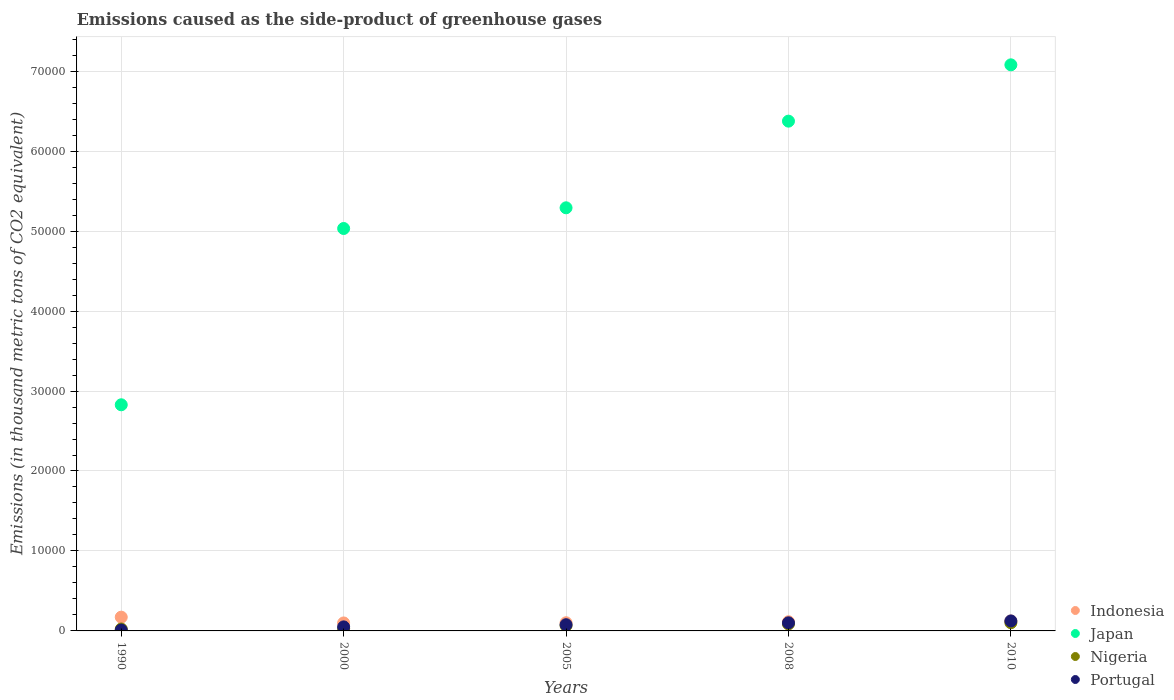How many different coloured dotlines are there?
Make the answer very short. 4. What is the emissions caused as the side-product of greenhouse gases in Portugal in 2000?
Your answer should be very brief. 505.3. Across all years, what is the maximum emissions caused as the side-product of greenhouse gases in Nigeria?
Your answer should be very brief. 1023. Across all years, what is the minimum emissions caused as the side-product of greenhouse gases in Portugal?
Offer a terse response. 110.8. In which year was the emissions caused as the side-product of greenhouse gases in Japan maximum?
Ensure brevity in your answer.  2010. In which year was the emissions caused as the side-product of greenhouse gases in Nigeria minimum?
Provide a short and direct response. 1990. What is the total emissions caused as the side-product of greenhouse gases in Nigeria in the graph?
Offer a very short reply. 3076.7. What is the difference between the emissions caused as the side-product of greenhouse gases in Nigeria in 1990 and that in 2008?
Your answer should be compact. -633.3. What is the difference between the emissions caused as the side-product of greenhouse gases in Indonesia in 2000 and the emissions caused as the side-product of greenhouse gases in Nigeria in 2008?
Your answer should be very brief. 122.2. What is the average emissions caused as the side-product of greenhouse gases in Portugal per year?
Ensure brevity in your answer.  730.74. In how many years, is the emissions caused as the side-product of greenhouse gases in Japan greater than 62000 thousand metric tons?
Make the answer very short. 2. What is the ratio of the emissions caused as the side-product of greenhouse gases in Nigeria in 2005 to that in 2008?
Ensure brevity in your answer.  0.76. What is the difference between the highest and the second highest emissions caused as the side-product of greenhouse gases in Portugal?
Your answer should be compact. 235.3. What is the difference between the highest and the lowest emissions caused as the side-product of greenhouse gases in Nigeria?
Your answer should be compact. 781.1. In how many years, is the emissions caused as the side-product of greenhouse gases in Portugal greater than the average emissions caused as the side-product of greenhouse gases in Portugal taken over all years?
Your answer should be compact. 3. Is it the case that in every year, the sum of the emissions caused as the side-product of greenhouse gases in Indonesia and emissions caused as the side-product of greenhouse gases in Nigeria  is greater than the sum of emissions caused as the side-product of greenhouse gases in Japan and emissions caused as the side-product of greenhouse gases in Portugal?
Give a very brief answer. No. Is it the case that in every year, the sum of the emissions caused as the side-product of greenhouse gases in Portugal and emissions caused as the side-product of greenhouse gases in Nigeria  is greater than the emissions caused as the side-product of greenhouse gases in Indonesia?
Ensure brevity in your answer.  No. Does the emissions caused as the side-product of greenhouse gases in Indonesia monotonically increase over the years?
Provide a succinct answer. No. Is the emissions caused as the side-product of greenhouse gases in Indonesia strictly greater than the emissions caused as the side-product of greenhouse gases in Japan over the years?
Provide a succinct answer. No. How many dotlines are there?
Provide a succinct answer. 4. How many years are there in the graph?
Offer a very short reply. 5. How many legend labels are there?
Your answer should be very brief. 4. What is the title of the graph?
Make the answer very short. Emissions caused as the side-product of greenhouse gases. What is the label or title of the Y-axis?
Your answer should be compact. Emissions (in thousand metric tons of CO2 equivalent). What is the Emissions (in thousand metric tons of CO2 equivalent) of Indonesia in 1990?
Provide a succinct answer. 1720.7. What is the Emissions (in thousand metric tons of CO2 equivalent) in Japan in 1990?
Keep it short and to the point. 2.83e+04. What is the Emissions (in thousand metric tons of CO2 equivalent) of Nigeria in 1990?
Offer a terse response. 241.9. What is the Emissions (in thousand metric tons of CO2 equivalent) of Portugal in 1990?
Provide a short and direct response. 110.8. What is the Emissions (in thousand metric tons of CO2 equivalent) of Indonesia in 2000?
Offer a very short reply. 997.4. What is the Emissions (in thousand metric tons of CO2 equivalent) of Japan in 2000?
Make the answer very short. 5.03e+04. What is the Emissions (in thousand metric tons of CO2 equivalent) in Nigeria in 2000?
Give a very brief answer. 270.9. What is the Emissions (in thousand metric tons of CO2 equivalent) in Portugal in 2000?
Make the answer very short. 505.3. What is the Emissions (in thousand metric tons of CO2 equivalent) of Indonesia in 2005?
Your answer should be very brief. 1020.5. What is the Emissions (in thousand metric tons of CO2 equivalent) in Japan in 2005?
Your answer should be compact. 5.29e+04. What is the Emissions (in thousand metric tons of CO2 equivalent) in Nigeria in 2005?
Keep it short and to the point. 665.7. What is the Emissions (in thousand metric tons of CO2 equivalent) in Portugal in 2005?
Offer a very short reply. 776.9. What is the Emissions (in thousand metric tons of CO2 equivalent) of Indonesia in 2008?
Offer a very short reply. 1146. What is the Emissions (in thousand metric tons of CO2 equivalent) of Japan in 2008?
Provide a short and direct response. 6.38e+04. What is the Emissions (in thousand metric tons of CO2 equivalent) in Nigeria in 2008?
Make the answer very short. 875.2. What is the Emissions (in thousand metric tons of CO2 equivalent) in Portugal in 2008?
Provide a succinct answer. 1012.7. What is the Emissions (in thousand metric tons of CO2 equivalent) in Indonesia in 2010?
Your response must be concise. 1241. What is the Emissions (in thousand metric tons of CO2 equivalent) of Japan in 2010?
Provide a succinct answer. 7.08e+04. What is the Emissions (in thousand metric tons of CO2 equivalent) of Nigeria in 2010?
Your answer should be very brief. 1023. What is the Emissions (in thousand metric tons of CO2 equivalent) in Portugal in 2010?
Provide a short and direct response. 1248. Across all years, what is the maximum Emissions (in thousand metric tons of CO2 equivalent) in Indonesia?
Your response must be concise. 1720.7. Across all years, what is the maximum Emissions (in thousand metric tons of CO2 equivalent) of Japan?
Your response must be concise. 7.08e+04. Across all years, what is the maximum Emissions (in thousand metric tons of CO2 equivalent) in Nigeria?
Give a very brief answer. 1023. Across all years, what is the maximum Emissions (in thousand metric tons of CO2 equivalent) of Portugal?
Ensure brevity in your answer.  1248. Across all years, what is the minimum Emissions (in thousand metric tons of CO2 equivalent) in Indonesia?
Offer a very short reply. 997.4. Across all years, what is the minimum Emissions (in thousand metric tons of CO2 equivalent) of Japan?
Your answer should be compact. 2.83e+04. Across all years, what is the minimum Emissions (in thousand metric tons of CO2 equivalent) in Nigeria?
Ensure brevity in your answer.  241.9. Across all years, what is the minimum Emissions (in thousand metric tons of CO2 equivalent) in Portugal?
Provide a short and direct response. 110.8. What is the total Emissions (in thousand metric tons of CO2 equivalent) of Indonesia in the graph?
Keep it short and to the point. 6125.6. What is the total Emissions (in thousand metric tons of CO2 equivalent) in Japan in the graph?
Ensure brevity in your answer.  2.66e+05. What is the total Emissions (in thousand metric tons of CO2 equivalent) of Nigeria in the graph?
Your response must be concise. 3076.7. What is the total Emissions (in thousand metric tons of CO2 equivalent) of Portugal in the graph?
Keep it short and to the point. 3653.7. What is the difference between the Emissions (in thousand metric tons of CO2 equivalent) of Indonesia in 1990 and that in 2000?
Give a very brief answer. 723.3. What is the difference between the Emissions (in thousand metric tons of CO2 equivalent) of Japan in 1990 and that in 2000?
Your answer should be very brief. -2.20e+04. What is the difference between the Emissions (in thousand metric tons of CO2 equivalent) of Nigeria in 1990 and that in 2000?
Ensure brevity in your answer.  -29. What is the difference between the Emissions (in thousand metric tons of CO2 equivalent) in Portugal in 1990 and that in 2000?
Make the answer very short. -394.5. What is the difference between the Emissions (in thousand metric tons of CO2 equivalent) of Indonesia in 1990 and that in 2005?
Provide a succinct answer. 700.2. What is the difference between the Emissions (in thousand metric tons of CO2 equivalent) of Japan in 1990 and that in 2005?
Offer a terse response. -2.46e+04. What is the difference between the Emissions (in thousand metric tons of CO2 equivalent) of Nigeria in 1990 and that in 2005?
Give a very brief answer. -423.8. What is the difference between the Emissions (in thousand metric tons of CO2 equivalent) in Portugal in 1990 and that in 2005?
Your answer should be very brief. -666.1. What is the difference between the Emissions (in thousand metric tons of CO2 equivalent) of Indonesia in 1990 and that in 2008?
Give a very brief answer. 574.7. What is the difference between the Emissions (in thousand metric tons of CO2 equivalent) in Japan in 1990 and that in 2008?
Keep it short and to the point. -3.55e+04. What is the difference between the Emissions (in thousand metric tons of CO2 equivalent) of Nigeria in 1990 and that in 2008?
Keep it short and to the point. -633.3. What is the difference between the Emissions (in thousand metric tons of CO2 equivalent) of Portugal in 1990 and that in 2008?
Make the answer very short. -901.9. What is the difference between the Emissions (in thousand metric tons of CO2 equivalent) of Indonesia in 1990 and that in 2010?
Provide a succinct answer. 479.7. What is the difference between the Emissions (in thousand metric tons of CO2 equivalent) in Japan in 1990 and that in 2010?
Give a very brief answer. -4.25e+04. What is the difference between the Emissions (in thousand metric tons of CO2 equivalent) in Nigeria in 1990 and that in 2010?
Your answer should be very brief. -781.1. What is the difference between the Emissions (in thousand metric tons of CO2 equivalent) in Portugal in 1990 and that in 2010?
Your response must be concise. -1137.2. What is the difference between the Emissions (in thousand metric tons of CO2 equivalent) in Indonesia in 2000 and that in 2005?
Your response must be concise. -23.1. What is the difference between the Emissions (in thousand metric tons of CO2 equivalent) in Japan in 2000 and that in 2005?
Offer a terse response. -2588.2. What is the difference between the Emissions (in thousand metric tons of CO2 equivalent) of Nigeria in 2000 and that in 2005?
Give a very brief answer. -394.8. What is the difference between the Emissions (in thousand metric tons of CO2 equivalent) in Portugal in 2000 and that in 2005?
Provide a succinct answer. -271.6. What is the difference between the Emissions (in thousand metric tons of CO2 equivalent) in Indonesia in 2000 and that in 2008?
Offer a terse response. -148.6. What is the difference between the Emissions (in thousand metric tons of CO2 equivalent) in Japan in 2000 and that in 2008?
Give a very brief answer. -1.34e+04. What is the difference between the Emissions (in thousand metric tons of CO2 equivalent) of Nigeria in 2000 and that in 2008?
Provide a short and direct response. -604.3. What is the difference between the Emissions (in thousand metric tons of CO2 equivalent) in Portugal in 2000 and that in 2008?
Provide a succinct answer. -507.4. What is the difference between the Emissions (in thousand metric tons of CO2 equivalent) in Indonesia in 2000 and that in 2010?
Your response must be concise. -243.6. What is the difference between the Emissions (in thousand metric tons of CO2 equivalent) in Japan in 2000 and that in 2010?
Provide a succinct answer. -2.05e+04. What is the difference between the Emissions (in thousand metric tons of CO2 equivalent) of Nigeria in 2000 and that in 2010?
Give a very brief answer. -752.1. What is the difference between the Emissions (in thousand metric tons of CO2 equivalent) of Portugal in 2000 and that in 2010?
Your answer should be compact. -742.7. What is the difference between the Emissions (in thousand metric tons of CO2 equivalent) in Indonesia in 2005 and that in 2008?
Your answer should be compact. -125.5. What is the difference between the Emissions (in thousand metric tons of CO2 equivalent) of Japan in 2005 and that in 2008?
Offer a very short reply. -1.08e+04. What is the difference between the Emissions (in thousand metric tons of CO2 equivalent) of Nigeria in 2005 and that in 2008?
Provide a succinct answer. -209.5. What is the difference between the Emissions (in thousand metric tons of CO2 equivalent) in Portugal in 2005 and that in 2008?
Your answer should be very brief. -235.8. What is the difference between the Emissions (in thousand metric tons of CO2 equivalent) in Indonesia in 2005 and that in 2010?
Ensure brevity in your answer.  -220.5. What is the difference between the Emissions (in thousand metric tons of CO2 equivalent) in Japan in 2005 and that in 2010?
Your response must be concise. -1.79e+04. What is the difference between the Emissions (in thousand metric tons of CO2 equivalent) of Nigeria in 2005 and that in 2010?
Provide a short and direct response. -357.3. What is the difference between the Emissions (in thousand metric tons of CO2 equivalent) in Portugal in 2005 and that in 2010?
Keep it short and to the point. -471.1. What is the difference between the Emissions (in thousand metric tons of CO2 equivalent) in Indonesia in 2008 and that in 2010?
Give a very brief answer. -95. What is the difference between the Emissions (in thousand metric tons of CO2 equivalent) of Japan in 2008 and that in 2010?
Your response must be concise. -7042.3. What is the difference between the Emissions (in thousand metric tons of CO2 equivalent) in Nigeria in 2008 and that in 2010?
Make the answer very short. -147.8. What is the difference between the Emissions (in thousand metric tons of CO2 equivalent) of Portugal in 2008 and that in 2010?
Offer a terse response. -235.3. What is the difference between the Emissions (in thousand metric tons of CO2 equivalent) in Indonesia in 1990 and the Emissions (in thousand metric tons of CO2 equivalent) in Japan in 2000?
Provide a succinct answer. -4.86e+04. What is the difference between the Emissions (in thousand metric tons of CO2 equivalent) of Indonesia in 1990 and the Emissions (in thousand metric tons of CO2 equivalent) of Nigeria in 2000?
Your response must be concise. 1449.8. What is the difference between the Emissions (in thousand metric tons of CO2 equivalent) in Indonesia in 1990 and the Emissions (in thousand metric tons of CO2 equivalent) in Portugal in 2000?
Your response must be concise. 1215.4. What is the difference between the Emissions (in thousand metric tons of CO2 equivalent) of Japan in 1990 and the Emissions (in thousand metric tons of CO2 equivalent) of Nigeria in 2000?
Provide a succinct answer. 2.80e+04. What is the difference between the Emissions (in thousand metric tons of CO2 equivalent) of Japan in 1990 and the Emissions (in thousand metric tons of CO2 equivalent) of Portugal in 2000?
Give a very brief answer. 2.78e+04. What is the difference between the Emissions (in thousand metric tons of CO2 equivalent) of Nigeria in 1990 and the Emissions (in thousand metric tons of CO2 equivalent) of Portugal in 2000?
Provide a short and direct response. -263.4. What is the difference between the Emissions (in thousand metric tons of CO2 equivalent) of Indonesia in 1990 and the Emissions (in thousand metric tons of CO2 equivalent) of Japan in 2005?
Your answer should be compact. -5.12e+04. What is the difference between the Emissions (in thousand metric tons of CO2 equivalent) of Indonesia in 1990 and the Emissions (in thousand metric tons of CO2 equivalent) of Nigeria in 2005?
Ensure brevity in your answer.  1055. What is the difference between the Emissions (in thousand metric tons of CO2 equivalent) of Indonesia in 1990 and the Emissions (in thousand metric tons of CO2 equivalent) of Portugal in 2005?
Offer a terse response. 943.8. What is the difference between the Emissions (in thousand metric tons of CO2 equivalent) of Japan in 1990 and the Emissions (in thousand metric tons of CO2 equivalent) of Nigeria in 2005?
Your answer should be compact. 2.76e+04. What is the difference between the Emissions (in thousand metric tons of CO2 equivalent) in Japan in 1990 and the Emissions (in thousand metric tons of CO2 equivalent) in Portugal in 2005?
Make the answer very short. 2.75e+04. What is the difference between the Emissions (in thousand metric tons of CO2 equivalent) in Nigeria in 1990 and the Emissions (in thousand metric tons of CO2 equivalent) in Portugal in 2005?
Your response must be concise. -535. What is the difference between the Emissions (in thousand metric tons of CO2 equivalent) in Indonesia in 1990 and the Emissions (in thousand metric tons of CO2 equivalent) in Japan in 2008?
Your answer should be very brief. -6.20e+04. What is the difference between the Emissions (in thousand metric tons of CO2 equivalent) of Indonesia in 1990 and the Emissions (in thousand metric tons of CO2 equivalent) of Nigeria in 2008?
Give a very brief answer. 845.5. What is the difference between the Emissions (in thousand metric tons of CO2 equivalent) in Indonesia in 1990 and the Emissions (in thousand metric tons of CO2 equivalent) in Portugal in 2008?
Provide a short and direct response. 708. What is the difference between the Emissions (in thousand metric tons of CO2 equivalent) of Japan in 1990 and the Emissions (in thousand metric tons of CO2 equivalent) of Nigeria in 2008?
Your answer should be compact. 2.74e+04. What is the difference between the Emissions (in thousand metric tons of CO2 equivalent) of Japan in 1990 and the Emissions (in thousand metric tons of CO2 equivalent) of Portugal in 2008?
Give a very brief answer. 2.73e+04. What is the difference between the Emissions (in thousand metric tons of CO2 equivalent) of Nigeria in 1990 and the Emissions (in thousand metric tons of CO2 equivalent) of Portugal in 2008?
Make the answer very short. -770.8. What is the difference between the Emissions (in thousand metric tons of CO2 equivalent) of Indonesia in 1990 and the Emissions (in thousand metric tons of CO2 equivalent) of Japan in 2010?
Offer a terse response. -6.91e+04. What is the difference between the Emissions (in thousand metric tons of CO2 equivalent) in Indonesia in 1990 and the Emissions (in thousand metric tons of CO2 equivalent) in Nigeria in 2010?
Your response must be concise. 697.7. What is the difference between the Emissions (in thousand metric tons of CO2 equivalent) of Indonesia in 1990 and the Emissions (in thousand metric tons of CO2 equivalent) of Portugal in 2010?
Keep it short and to the point. 472.7. What is the difference between the Emissions (in thousand metric tons of CO2 equivalent) in Japan in 1990 and the Emissions (in thousand metric tons of CO2 equivalent) in Nigeria in 2010?
Provide a succinct answer. 2.73e+04. What is the difference between the Emissions (in thousand metric tons of CO2 equivalent) in Japan in 1990 and the Emissions (in thousand metric tons of CO2 equivalent) in Portugal in 2010?
Provide a succinct answer. 2.70e+04. What is the difference between the Emissions (in thousand metric tons of CO2 equivalent) of Nigeria in 1990 and the Emissions (in thousand metric tons of CO2 equivalent) of Portugal in 2010?
Provide a short and direct response. -1006.1. What is the difference between the Emissions (in thousand metric tons of CO2 equivalent) in Indonesia in 2000 and the Emissions (in thousand metric tons of CO2 equivalent) in Japan in 2005?
Offer a terse response. -5.19e+04. What is the difference between the Emissions (in thousand metric tons of CO2 equivalent) of Indonesia in 2000 and the Emissions (in thousand metric tons of CO2 equivalent) of Nigeria in 2005?
Keep it short and to the point. 331.7. What is the difference between the Emissions (in thousand metric tons of CO2 equivalent) of Indonesia in 2000 and the Emissions (in thousand metric tons of CO2 equivalent) of Portugal in 2005?
Your answer should be compact. 220.5. What is the difference between the Emissions (in thousand metric tons of CO2 equivalent) of Japan in 2000 and the Emissions (in thousand metric tons of CO2 equivalent) of Nigeria in 2005?
Give a very brief answer. 4.97e+04. What is the difference between the Emissions (in thousand metric tons of CO2 equivalent) in Japan in 2000 and the Emissions (in thousand metric tons of CO2 equivalent) in Portugal in 2005?
Give a very brief answer. 4.95e+04. What is the difference between the Emissions (in thousand metric tons of CO2 equivalent) of Nigeria in 2000 and the Emissions (in thousand metric tons of CO2 equivalent) of Portugal in 2005?
Your response must be concise. -506. What is the difference between the Emissions (in thousand metric tons of CO2 equivalent) in Indonesia in 2000 and the Emissions (in thousand metric tons of CO2 equivalent) in Japan in 2008?
Ensure brevity in your answer.  -6.28e+04. What is the difference between the Emissions (in thousand metric tons of CO2 equivalent) in Indonesia in 2000 and the Emissions (in thousand metric tons of CO2 equivalent) in Nigeria in 2008?
Provide a short and direct response. 122.2. What is the difference between the Emissions (in thousand metric tons of CO2 equivalent) in Indonesia in 2000 and the Emissions (in thousand metric tons of CO2 equivalent) in Portugal in 2008?
Keep it short and to the point. -15.3. What is the difference between the Emissions (in thousand metric tons of CO2 equivalent) in Japan in 2000 and the Emissions (in thousand metric tons of CO2 equivalent) in Nigeria in 2008?
Offer a terse response. 4.95e+04. What is the difference between the Emissions (in thousand metric tons of CO2 equivalent) in Japan in 2000 and the Emissions (in thousand metric tons of CO2 equivalent) in Portugal in 2008?
Your answer should be compact. 4.93e+04. What is the difference between the Emissions (in thousand metric tons of CO2 equivalent) in Nigeria in 2000 and the Emissions (in thousand metric tons of CO2 equivalent) in Portugal in 2008?
Your answer should be very brief. -741.8. What is the difference between the Emissions (in thousand metric tons of CO2 equivalent) in Indonesia in 2000 and the Emissions (in thousand metric tons of CO2 equivalent) in Japan in 2010?
Give a very brief answer. -6.98e+04. What is the difference between the Emissions (in thousand metric tons of CO2 equivalent) in Indonesia in 2000 and the Emissions (in thousand metric tons of CO2 equivalent) in Nigeria in 2010?
Give a very brief answer. -25.6. What is the difference between the Emissions (in thousand metric tons of CO2 equivalent) in Indonesia in 2000 and the Emissions (in thousand metric tons of CO2 equivalent) in Portugal in 2010?
Your answer should be very brief. -250.6. What is the difference between the Emissions (in thousand metric tons of CO2 equivalent) in Japan in 2000 and the Emissions (in thousand metric tons of CO2 equivalent) in Nigeria in 2010?
Offer a very short reply. 4.93e+04. What is the difference between the Emissions (in thousand metric tons of CO2 equivalent) of Japan in 2000 and the Emissions (in thousand metric tons of CO2 equivalent) of Portugal in 2010?
Offer a very short reply. 4.91e+04. What is the difference between the Emissions (in thousand metric tons of CO2 equivalent) in Nigeria in 2000 and the Emissions (in thousand metric tons of CO2 equivalent) in Portugal in 2010?
Keep it short and to the point. -977.1. What is the difference between the Emissions (in thousand metric tons of CO2 equivalent) in Indonesia in 2005 and the Emissions (in thousand metric tons of CO2 equivalent) in Japan in 2008?
Your response must be concise. -6.27e+04. What is the difference between the Emissions (in thousand metric tons of CO2 equivalent) of Indonesia in 2005 and the Emissions (in thousand metric tons of CO2 equivalent) of Nigeria in 2008?
Ensure brevity in your answer.  145.3. What is the difference between the Emissions (in thousand metric tons of CO2 equivalent) in Japan in 2005 and the Emissions (in thousand metric tons of CO2 equivalent) in Nigeria in 2008?
Keep it short and to the point. 5.20e+04. What is the difference between the Emissions (in thousand metric tons of CO2 equivalent) in Japan in 2005 and the Emissions (in thousand metric tons of CO2 equivalent) in Portugal in 2008?
Ensure brevity in your answer.  5.19e+04. What is the difference between the Emissions (in thousand metric tons of CO2 equivalent) in Nigeria in 2005 and the Emissions (in thousand metric tons of CO2 equivalent) in Portugal in 2008?
Offer a terse response. -347. What is the difference between the Emissions (in thousand metric tons of CO2 equivalent) of Indonesia in 2005 and the Emissions (in thousand metric tons of CO2 equivalent) of Japan in 2010?
Your answer should be compact. -6.98e+04. What is the difference between the Emissions (in thousand metric tons of CO2 equivalent) in Indonesia in 2005 and the Emissions (in thousand metric tons of CO2 equivalent) in Nigeria in 2010?
Ensure brevity in your answer.  -2.5. What is the difference between the Emissions (in thousand metric tons of CO2 equivalent) in Indonesia in 2005 and the Emissions (in thousand metric tons of CO2 equivalent) in Portugal in 2010?
Ensure brevity in your answer.  -227.5. What is the difference between the Emissions (in thousand metric tons of CO2 equivalent) in Japan in 2005 and the Emissions (in thousand metric tons of CO2 equivalent) in Nigeria in 2010?
Provide a short and direct response. 5.19e+04. What is the difference between the Emissions (in thousand metric tons of CO2 equivalent) in Japan in 2005 and the Emissions (in thousand metric tons of CO2 equivalent) in Portugal in 2010?
Make the answer very short. 5.17e+04. What is the difference between the Emissions (in thousand metric tons of CO2 equivalent) in Nigeria in 2005 and the Emissions (in thousand metric tons of CO2 equivalent) in Portugal in 2010?
Offer a terse response. -582.3. What is the difference between the Emissions (in thousand metric tons of CO2 equivalent) of Indonesia in 2008 and the Emissions (in thousand metric tons of CO2 equivalent) of Japan in 2010?
Ensure brevity in your answer.  -6.96e+04. What is the difference between the Emissions (in thousand metric tons of CO2 equivalent) in Indonesia in 2008 and the Emissions (in thousand metric tons of CO2 equivalent) in Nigeria in 2010?
Your response must be concise. 123. What is the difference between the Emissions (in thousand metric tons of CO2 equivalent) in Indonesia in 2008 and the Emissions (in thousand metric tons of CO2 equivalent) in Portugal in 2010?
Make the answer very short. -102. What is the difference between the Emissions (in thousand metric tons of CO2 equivalent) of Japan in 2008 and the Emissions (in thousand metric tons of CO2 equivalent) of Nigeria in 2010?
Your answer should be compact. 6.27e+04. What is the difference between the Emissions (in thousand metric tons of CO2 equivalent) in Japan in 2008 and the Emissions (in thousand metric tons of CO2 equivalent) in Portugal in 2010?
Offer a terse response. 6.25e+04. What is the difference between the Emissions (in thousand metric tons of CO2 equivalent) in Nigeria in 2008 and the Emissions (in thousand metric tons of CO2 equivalent) in Portugal in 2010?
Offer a terse response. -372.8. What is the average Emissions (in thousand metric tons of CO2 equivalent) of Indonesia per year?
Provide a short and direct response. 1225.12. What is the average Emissions (in thousand metric tons of CO2 equivalent) of Japan per year?
Provide a short and direct response. 5.32e+04. What is the average Emissions (in thousand metric tons of CO2 equivalent) in Nigeria per year?
Provide a short and direct response. 615.34. What is the average Emissions (in thousand metric tons of CO2 equivalent) of Portugal per year?
Ensure brevity in your answer.  730.74. In the year 1990, what is the difference between the Emissions (in thousand metric tons of CO2 equivalent) of Indonesia and Emissions (in thousand metric tons of CO2 equivalent) of Japan?
Ensure brevity in your answer.  -2.66e+04. In the year 1990, what is the difference between the Emissions (in thousand metric tons of CO2 equivalent) in Indonesia and Emissions (in thousand metric tons of CO2 equivalent) in Nigeria?
Make the answer very short. 1478.8. In the year 1990, what is the difference between the Emissions (in thousand metric tons of CO2 equivalent) of Indonesia and Emissions (in thousand metric tons of CO2 equivalent) of Portugal?
Give a very brief answer. 1609.9. In the year 1990, what is the difference between the Emissions (in thousand metric tons of CO2 equivalent) of Japan and Emissions (in thousand metric tons of CO2 equivalent) of Nigeria?
Ensure brevity in your answer.  2.80e+04. In the year 1990, what is the difference between the Emissions (in thousand metric tons of CO2 equivalent) in Japan and Emissions (in thousand metric tons of CO2 equivalent) in Portugal?
Offer a terse response. 2.82e+04. In the year 1990, what is the difference between the Emissions (in thousand metric tons of CO2 equivalent) in Nigeria and Emissions (in thousand metric tons of CO2 equivalent) in Portugal?
Offer a very short reply. 131.1. In the year 2000, what is the difference between the Emissions (in thousand metric tons of CO2 equivalent) of Indonesia and Emissions (in thousand metric tons of CO2 equivalent) of Japan?
Keep it short and to the point. -4.93e+04. In the year 2000, what is the difference between the Emissions (in thousand metric tons of CO2 equivalent) in Indonesia and Emissions (in thousand metric tons of CO2 equivalent) in Nigeria?
Make the answer very short. 726.5. In the year 2000, what is the difference between the Emissions (in thousand metric tons of CO2 equivalent) of Indonesia and Emissions (in thousand metric tons of CO2 equivalent) of Portugal?
Keep it short and to the point. 492.1. In the year 2000, what is the difference between the Emissions (in thousand metric tons of CO2 equivalent) in Japan and Emissions (in thousand metric tons of CO2 equivalent) in Nigeria?
Provide a succinct answer. 5.01e+04. In the year 2000, what is the difference between the Emissions (in thousand metric tons of CO2 equivalent) of Japan and Emissions (in thousand metric tons of CO2 equivalent) of Portugal?
Offer a terse response. 4.98e+04. In the year 2000, what is the difference between the Emissions (in thousand metric tons of CO2 equivalent) of Nigeria and Emissions (in thousand metric tons of CO2 equivalent) of Portugal?
Your answer should be very brief. -234.4. In the year 2005, what is the difference between the Emissions (in thousand metric tons of CO2 equivalent) in Indonesia and Emissions (in thousand metric tons of CO2 equivalent) in Japan?
Provide a succinct answer. -5.19e+04. In the year 2005, what is the difference between the Emissions (in thousand metric tons of CO2 equivalent) in Indonesia and Emissions (in thousand metric tons of CO2 equivalent) in Nigeria?
Give a very brief answer. 354.8. In the year 2005, what is the difference between the Emissions (in thousand metric tons of CO2 equivalent) in Indonesia and Emissions (in thousand metric tons of CO2 equivalent) in Portugal?
Ensure brevity in your answer.  243.6. In the year 2005, what is the difference between the Emissions (in thousand metric tons of CO2 equivalent) in Japan and Emissions (in thousand metric tons of CO2 equivalent) in Nigeria?
Provide a short and direct response. 5.22e+04. In the year 2005, what is the difference between the Emissions (in thousand metric tons of CO2 equivalent) in Japan and Emissions (in thousand metric tons of CO2 equivalent) in Portugal?
Ensure brevity in your answer.  5.21e+04. In the year 2005, what is the difference between the Emissions (in thousand metric tons of CO2 equivalent) in Nigeria and Emissions (in thousand metric tons of CO2 equivalent) in Portugal?
Offer a very short reply. -111.2. In the year 2008, what is the difference between the Emissions (in thousand metric tons of CO2 equivalent) of Indonesia and Emissions (in thousand metric tons of CO2 equivalent) of Japan?
Your answer should be compact. -6.26e+04. In the year 2008, what is the difference between the Emissions (in thousand metric tons of CO2 equivalent) of Indonesia and Emissions (in thousand metric tons of CO2 equivalent) of Nigeria?
Your answer should be compact. 270.8. In the year 2008, what is the difference between the Emissions (in thousand metric tons of CO2 equivalent) in Indonesia and Emissions (in thousand metric tons of CO2 equivalent) in Portugal?
Your response must be concise. 133.3. In the year 2008, what is the difference between the Emissions (in thousand metric tons of CO2 equivalent) of Japan and Emissions (in thousand metric tons of CO2 equivalent) of Nigeria?
Keep it short and to the point. 6.29e+04. In the year 2008, what is the difference between the Emissions (in thousand metric tons of CO2 equivalent) of Japan and Emissions (in thousand metric tons of CO2 equivalent) of Portugal?
Keep it short and to the point. 6.27e+04. In the year 2008, what is the difference between the Emissions (in thousand metric tons of CO2 equivalent) in Nigeria and Emissions (in thousand metric tons of CO2 equivalent) in Portugal?
Your response must be concise. -137.5. In the year 2010, what is the difference between the Emissions (in thousand metric tons of CO2 equivalent) of Indonesia and Emissions (in thousand metric tons of CO2 equivalent) of Japan?
Ensure brevity in your answer.  -6.96e+04. In the year 2010, what is the difference between the Emissions (in thousand metric tons of CO2 equivalent) of Indonesia and Emissions (in thousand metric tons of CO2 equivalent) of Nigeria?
Make the answer very short. 218. In the year 2010, what is the difference between the Emissions (in thousand metric tons of CO2 equivalent) in Japan and Emissions (in thousand metric tons of CO2 equivalent) in Nigeria?
Ensure brevity in your answer.  6.98e+04. In the year 2010, what is the difference between the Emissions (in thousand metric tons of CO2 equivalent) in Japan and Emissions (in thousand metric tons of CO2 equivalent) in Portugal?
Your answer should be very brief. 6.95e+04. In the year 2010, what is the difference between the Emissions (in thousand metric tons of CO2 equivalent) of Nigeria and Emissions (in thousand metric tons of CO2 equivalent) of Portugal?
Give a very brief answer. -225. What is the ratio of the Emissions (in thousand metric tons of CO2 equivalent) in Indonesia in 1990 to that in 2000?
Keep it short and to the point. 1.73. What is the ratio of the Emissions (in thousand metric tons of CO2 equivalent) in Japan in 1990 to that in 2000?
Your response must be concise. 0.56. What is the ratio of the Emissions (in thousand metric tons of CO2 equivalent) in Nigeria in 1990 to that in 2000?
Offer a very short reply. 0.89. What is the ratio of the Emissions (in thousand metric tons of CO2 equivalent) in Portugal in 1990 to that in 2000?
Make the answer very short. 0.22. What is the ratio of the Emissions (in thousand metric tons of CO2 equivalent) of Indonesia in 1990 to that in 2005?
Offer a very short reply. 1.69. What is the ratio of the Emissions (in thousand metric tons of CO2 equivalent) in Japan in 1990 to that in 2005?
Give a very brief answer. 0.53. What is the ratio of the Emissions (in thousand metric tons of CO2 equivalent) in Nigeria in 1990 to that in 2005?
Offer a terse response. 0.36. What is the ratio of the Emissions (in thousand metric tons of CO2 equivalent) of Portugal in 1990 to that in 2005?
Your answer should be compact. 0.14. What is the ratio of the Emissions (in thousand metric tons of CO2 equivalent) in Indonesia in 1990 to that in 2008?
Your answer should be compact. 1.5. What is the ratio of the Emissions (in thousand metric tons of CO2 equivalent) in Japan in 1990 to that in 2008?
Your response must be concise. 0.44. What is the ratio of the Emissions (in thousand metric tons of CO2 equivalent) in Nigeria in 1990 to that in 2008?
Make the answer very short. 0.28. What is the ratio of the Emissions (in thousand metric tons of CO2 equivalent) of Portugal in 1990 to that in 2008?
Keep it short and to the point. 0.11. What is the ratio of the Emissions (in thousand metric tons of CO2 equivalent) of Indonesia in 1990 to that in 2010?
Ensure brevity in your answer.  1.39. What is the ratio of the Emissions (in thousand metric tons of CO2 equivalent) in Japan in 1990 to that in 2010?
Give a very brief answer. 0.4. What is the ratio of the Emissions (in thousand metric tons of CO2 equivalent) of Nigeria in 1990 to that in 2010?
Your answer should be very brief. 0.24. What is the ratio of the Emissions (in thousand metric tons of CO2 equivalent) in Portugal in 1990 to that in 2010?
Make the answer very short. 0.09. What is the ratio of the Emissions (in thousand metric tons of CO2 equivalent) in Indonesia in 2000 to that in 2005?
Your answer should be compact. 0.98. What is the ratio of the Emissions (in thousand metric tons of CO2 equivalent) in Japan in 2000 to that in 2005?
Your answer should be very brief. 0.95. What is the ratio of the Emissions (in thousand metric tons of CO2 equivalent) of Nigeria in 2000 to that in 2005?
Provide a short and direct response. 0.41. What is the ratio of the Emissions (in thousand metric tons of CO2 equivalent) in Portugal in 2000 to that in 2005?
Offer a terse response. 0.65. What is the ratio of the Emissions (in thousand metric tons of CO2 equivalent) of Indonesia in 2000 to that in 2008?
Make the answer very short. 0.87. What is the ratio of the Emissions (in thousand metric tons of CO2 equivalent) of Japan in 2000 to that in 2008?
Provide a short and direct response. 0.79. What is the ratio of the Emissions (in thousand metric tons of CO2 equivalent) of Nigeria in 2000 to that in 2008?
Provide a succinct answer. 0.31. What is the ratio of the Emissions (in thousand metric tons of CO2 equivalent) in Portugal in 2000 to that in 2008?
Make the answer very short. 0.5. What is the ratio of the Emissions (in thousand metric tons of CO2 equivalent) of Indonesia in 2000 to that in 2010?
Ensure brevity in your answer.  0.8. What is the ratio of the Emissions (in thousand metric tons of CO2 equivalent) in Japan in 2000 to that in 2010?
Offer a very short reply. 0.71. What is the ratio of the Emissions (in thousand metric tons of CO2 equivalent) in Nigeria in 2000 to that in 2010?
Your answer should be very brief. 0.26. What is the ratio of the Emissions (in thousand metric tons of CO2 equivalent) in Portugal in 2000 to that in 2010?
Offer a very short reply. 0.4. What is the ratio of the Emissions (in thousand metric tons of CO2 equivalent) of Indonesia in 2005 to that in 2008?
Your answer should be very brief. 0.89. What is the ratio of the Emissions (in thousand metric tons of CO2 equivalent) of Japan in 2005 to that in 2008?
Your answer should be compact. 0.83. What is the ratio of the Emissions (in thousand metric tons of CO2 equivalent) in Nigeria in 2005 to that in 2008?
Offer a terse response. 0.76. What is the ratio of the Emissions (in thousand metric tons of CO2 equivalent) in Portugal in 2005 to that in 2008?
Your response must be concise. 0.77. What is the ratio of the Emissions (in thousand metric tons of CO2 equivalent) of Indonesia in 2005 to that in 2010?
Provide a succinct answer. 0.82. What is the ratio of the Emissions (in thousand metric tons of CO2 equivalent) of Japan in 2005 to that in 2010?
Give a very brief answer. 0.75. What is the ratio of the Emissions (in thousand metric tons of CO2 equivalent) of Nigeria in 2005 to that in 2010?
Your response must be concise. 0.65. What is the ratio of the Emissions (in thousand metric tons of CO2 equivalent) in Portugal in 2005 to that in 2010?
Ensure brevity in your answer.  0.62. What is the ratio of the Emissions (in thousand metric tons of CO2 equivalent) of Indonesia in 2008 to that in 2010?
Ensure brevity in your answer.  0.92. What is the ratio of the Emissions (in thousand metric tons of CO2 equivalent) of Japan in 2008 to that in 2010?
Provide a succinct answer. 0.9. What is the ratio of the Emissions (in thousand metric tons of CO2 equivalent) in Nigeria in 2008 to that in 2010?
Ensure brevity in your answer.  0.86. What is the ratio of the Emissions (in thousand metric tons of CO2 equivalent) of Portugal in 2008 to that in 2010?
Your answer should be compact. 0.81. What is the difference between the highest and the second highest Emissions (in thousand metric tons of CO2 equivalent) of Indonesia?
Provide a short and direct response. 479.7. What is the difference between the highest and the second highest Emissions (in thousand metric tons of CO2 equivalent) in Japan?
Offer a terse response. 7042.3. What is the difference between the highest and the second highest Emissions (in thousand metric tons of CO2 equivalent) of Nigeria?
Keep it short and to the point. 147.8. What is the difference between the highest and the second highest Emissions (in thousand metric tons of CO2 equivalent) of Portugal?
Provide a succinct answer. 235.3. What is the difference between the highest and the lowest Emissions (in thousand metric tons of CO2 equivalent) in Indonesia?
Your answer should be compact. 723.3. What is the difference between the highest and the lowest Emissions (in thousand metric tons of CO2 equivalent) of Japan?
Provide a succinct answer. 4.25e+04. What is the difference between the highest and the lowest Emissions (in thousand metric tons of CO2 equivalent) of Nigeria?
Offer a terse response. 781.1. What is the difference between the highest and the lowest Emissions (in thousand metric tons of CO2 equivalent) in Portugal?
Offer a very short reply. 1137.2. 